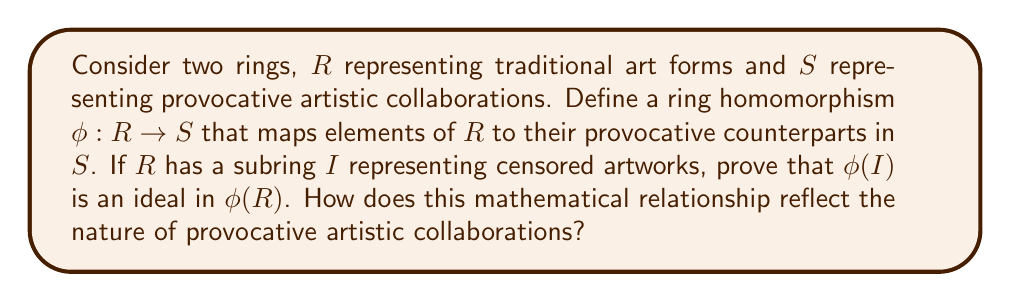Show me your answer to this math problem. Let's approach this step-by-step:

1) First, recall that a ring homomorphism $\phi: R \rightarrow S$ preserves the ring operations. For all $a, b \in R$:
   
   $\phi(a + b) = \phi(a) + \phi(b)$
   $\phi(ab) = \phi(a)\phi(b)$

2) Now, let's consider $\phi(I)$, where $I$ is a subring of $R$. We need to prove that $\phi(I)$ is an ideal in $\phi(R)$.

3) To prove that $\phi(I)$ is an ideal in $\phi(R)$, we need to show:
   
   a) $\phi(I)$ is closed under subtraction
   b) For any $r \in \phi(R)$ and $x \in \phi(I)$, both $rx$ and $xr$ are in $\phi(I)$

4) For closure under subtraction:
   Let $x, y \in \phi(I)$. Then $x = \phi(a)$ and $y = \phi(b)$ for some $a, b \in I$.
   $x - y = \phi(a) - \phi(b) = \phi(a - b)$ (since $\phi$ is a homomorphism)
   Since $I$ is a subring, $a - b \in I$, so $\phi(a - b) \in \phi(I)$.

5) For the second condition:
   Let $r \in \phi(R)$ and $x \in \phi(I)$. Then $r = \phi(c)$ for some $c \in R$, and $x = \phi(a)$ for some $a \in I$.
   $rx = \phi(c)\phi(a) = \phi(ca)$ (since $\phi$ is a homomorphism)
   Since $I$ is a subring, $ca \in I$, so $\phi(ca) \in \phi(I)$.
   Similarly, $xr = \phi(ac) \in \phi(I)$.

6) Therefore, $\phi(I)$ is indeed an ideal in $\phi(R)$.

This mathematical relationship reflects the nature of provocative artistic collaborations in several ways:

- The ring homomorphism $\phi$ represents the transformation of traditional art forms into provocative collaborations.
- The preservation of structure under $\phi$ mirrors how provocative art often maintains recognizable elements of traditional forms.
- The subring $I$ of censored artworks maps to an ideal in the image, suggesting that even "censored" ideas can find expression in provocative collaborations, potentially becoming central themes.
- The ideal property of $\phi(I)$ in $\phi(R)$ indicates that these provocative elements can interact with and influence all aspects of the collaborative artistic space.
Answer: $\phi(I)$ is an ideal in $\phi(R)$, demonstrating that censored or controversial elements in traditional art forms can become integral, pervasive themes in provocative artistic collaborations. 